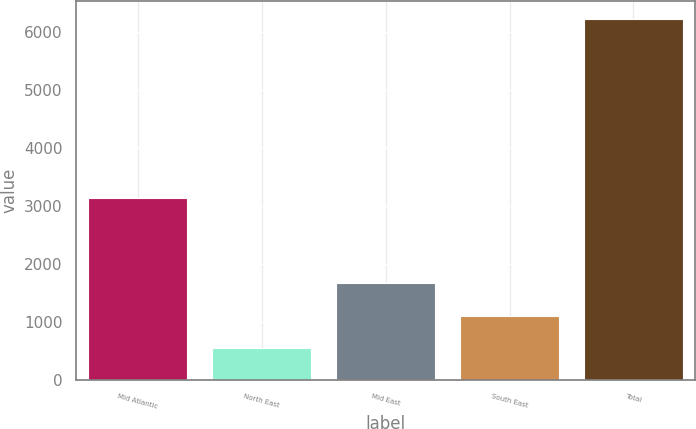Convert chart. <chart><loc_0><loc_0><loc_500><loc_500><bar_chart><fcel>Mid Atlantic<fcel>North East<fcel>Mid East<fcel>South East<fcel>Total<nl><fcel>3137<fcel>540<fcel>1677.8<fcel>1108.9<fcel>6229<nl></chart> 